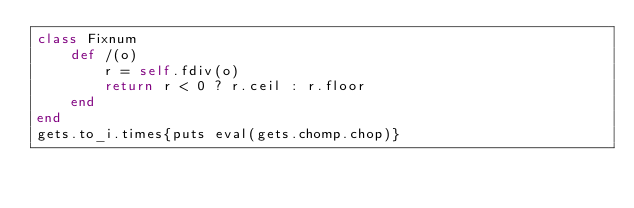Convert code to text. <code><loc_0><loc_0><loc_500><loc_500><_Ruby_>class Fixnum
	def /(o)
		r = self.fdiv(o)
		return r < 0 ? r.ceil : r.floor
	end
end
gets.to_i.times{puts eval(gets.chomp.chop)}</code> 